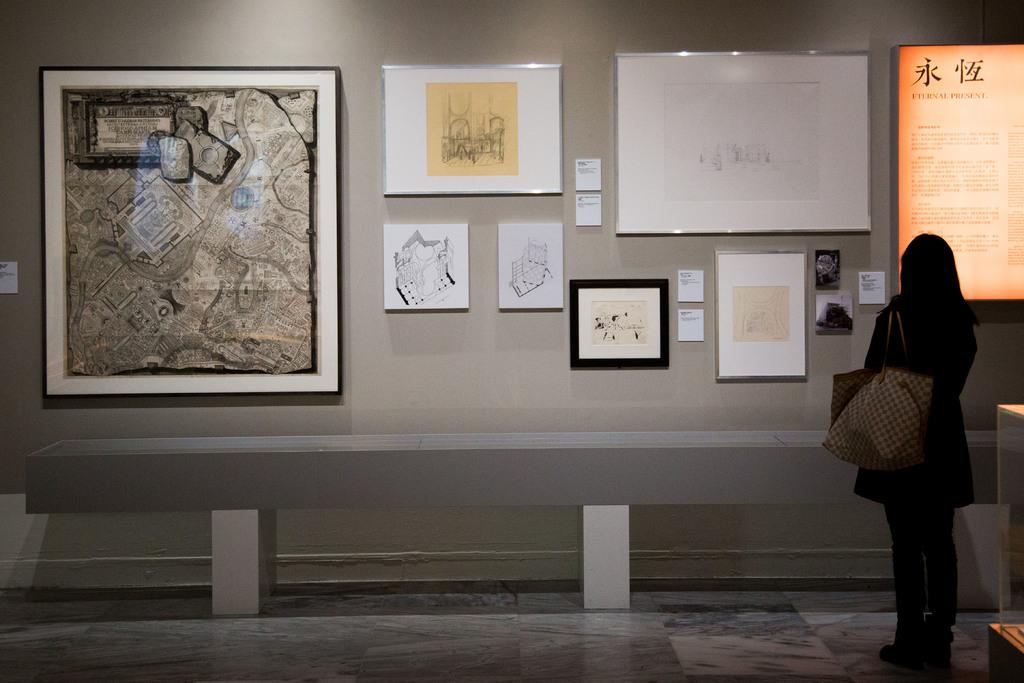What is the person in the image doing? The person is standing in the image. What is the person holding in the image? The person is holding a bag. What can be seen on the wall in the background of the image? There are frames attached to the wall in the background of the image. Can you see any sea creatures in the image? There is no sea or sea creatures present in the image. What type of spade is being used by the person in the image? There is no spade visible in the image; the person is holding a bag. 